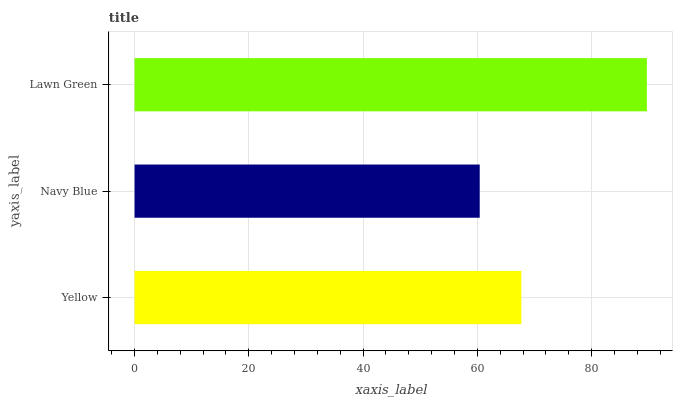Is Navy Blue the minimum?
Answer yes or no. Yes. Is Lawn Green the maximum?
Answer yes or no. Yes. Is Lawn Green the minimum?
Answer yes or no. No. Is Navy Blue the maximum?
Answer yes or no. No. Is Lawn Green greater than Navy Blue?
Answer yes or no. Yes. Is Navy Blue less than Lawn Green?
Answer yes or no. Yes. Is Navy Blue greater than Lawn Green?
Answer yes or no. No. Is Lawn Green less than Navy Blue?
Answer yes or no. No. Is Yellow the high median?
Answer yes or no. Yes. Is Yellow the low median?
Answer yes or no. Yes. Is Lawn Green the high median?
Answer yes or no. No. Is Navy Blue the low median?
Answer yes or no. No. 